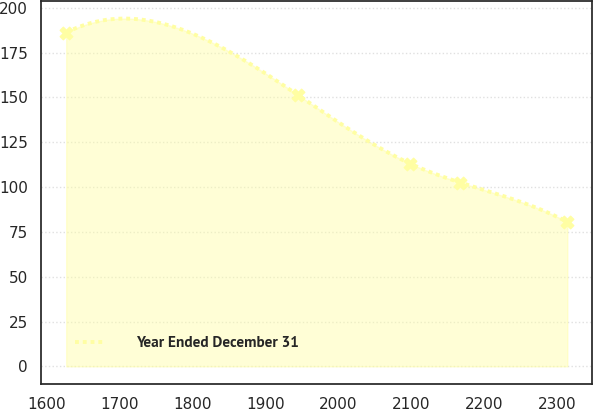<chart> <loc_0><loc_0><loc_500><loc_500><line_chart><ecel><fcel>Year Ended December 31<nl><fcel>1627.04<fcel>186.13<nl><fcel>1945.05<fcel>151.21<nl><fcel>2098.72<fcel>113.04<nl><fcel>2167.43<fcel>102.48<nl><fcel>2314.13<fcel>80.51<nl></chart> 